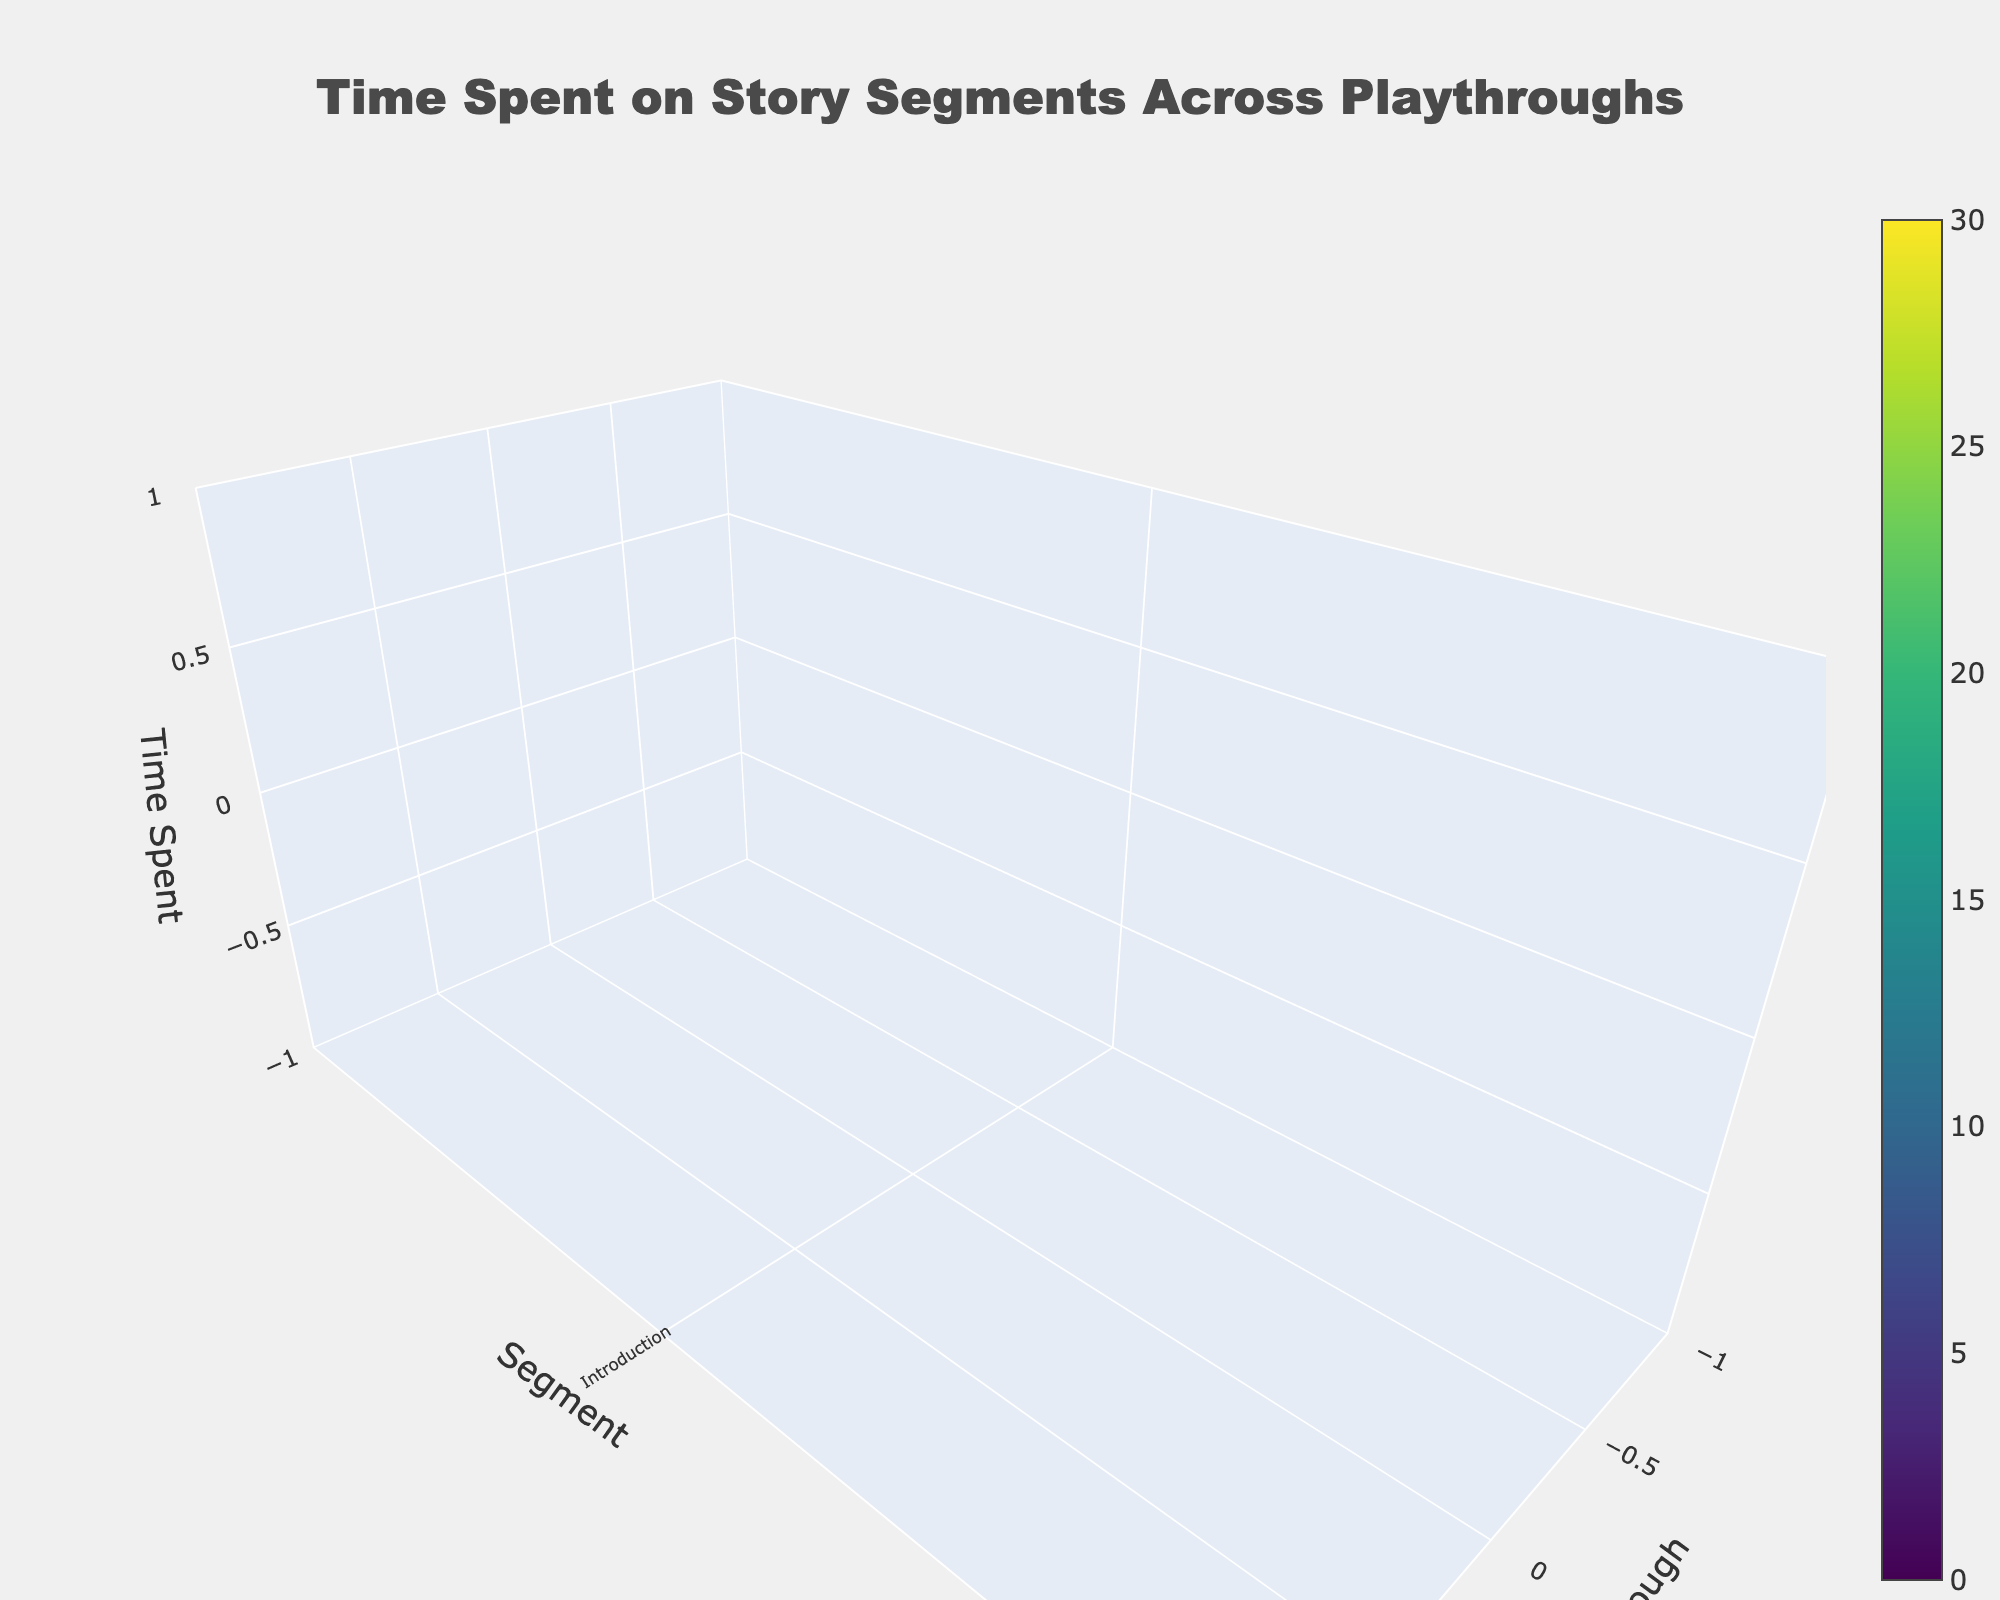What's the title of the figure? The title is prominent and typically placed at the top center of the figure. Here, the title is "Time Spent on Story Segments Across Playthroughs".
Answer: Time Spent on Story Segments Across Playthroughs How many story segments are visualized in the plot? There are unique y-axis labels representing different story segments. Counting these gives the total number of segments.
Answer: 7 Which playthrough experienced the most time during the Dragon Battle segment? The z-axis represents time spent, and the data indicates which playthrough and segment correspond to the highest value. The highest z-value for Dragon Battle is during Playthrough 2.
Answer: Playthrough 2 What is the shortest time spent in the Tavern Dialogue segment across all playthroughs? The z-axis represents time spent, and identifying the smallest z-value in the Tavern Dialogue segment shows the shortest time spent. The lowest value for Tavern Dialogue is 18.
Answer: 18 Compare the average time spent on the Mystery Puzzle segment across all playthroughs to that of the Introduction segment. Which is higher? Average time for Mystery Puzzle: (15 + 12 + 18) / 3 = 15. Average time for Introduction: (5 + 3 + 4) / 3 = 4. Therefore, the Mystery Puzzle segment has a higher average time spent.
Answer: Mystery Puzzle Which segment shows the highest variability in time spent across playthroughs? By examining z-values for each segment, the segment with the largest range between minimum and maximum values indicates the highest variability. For example, the Dragon Battle varies from 25 to 30, which is the highest observed range.
Answer: Dragon Battle Which story segment took the longest time in Playthrough 1? By examining the z-values for Playthrough 1 across all segments, the highest z-value will indicate the segment with the longest time spent. The largest value for Playthrough 1 is Dragon Battle at 25.
Answer: Dragon Battle How does the time spent in the Final Choice segment change from Playthrough 1 to Playthrough 2? Compare the z-values for Final Choice between Playthrough 1 and 2. The change is: Time_Playthrough_2 - Time_Playthrough_1 = 8 - 10 = -2. This indicates a decrease.
Answer: Decreases by 2 What's the total time spent on the Castle Encounter segment across all playthroughs? Sum the z-values for the Castle Encounter segment across all playthroughs: 12 + 15 + 10 = 37.
Answer: 37 